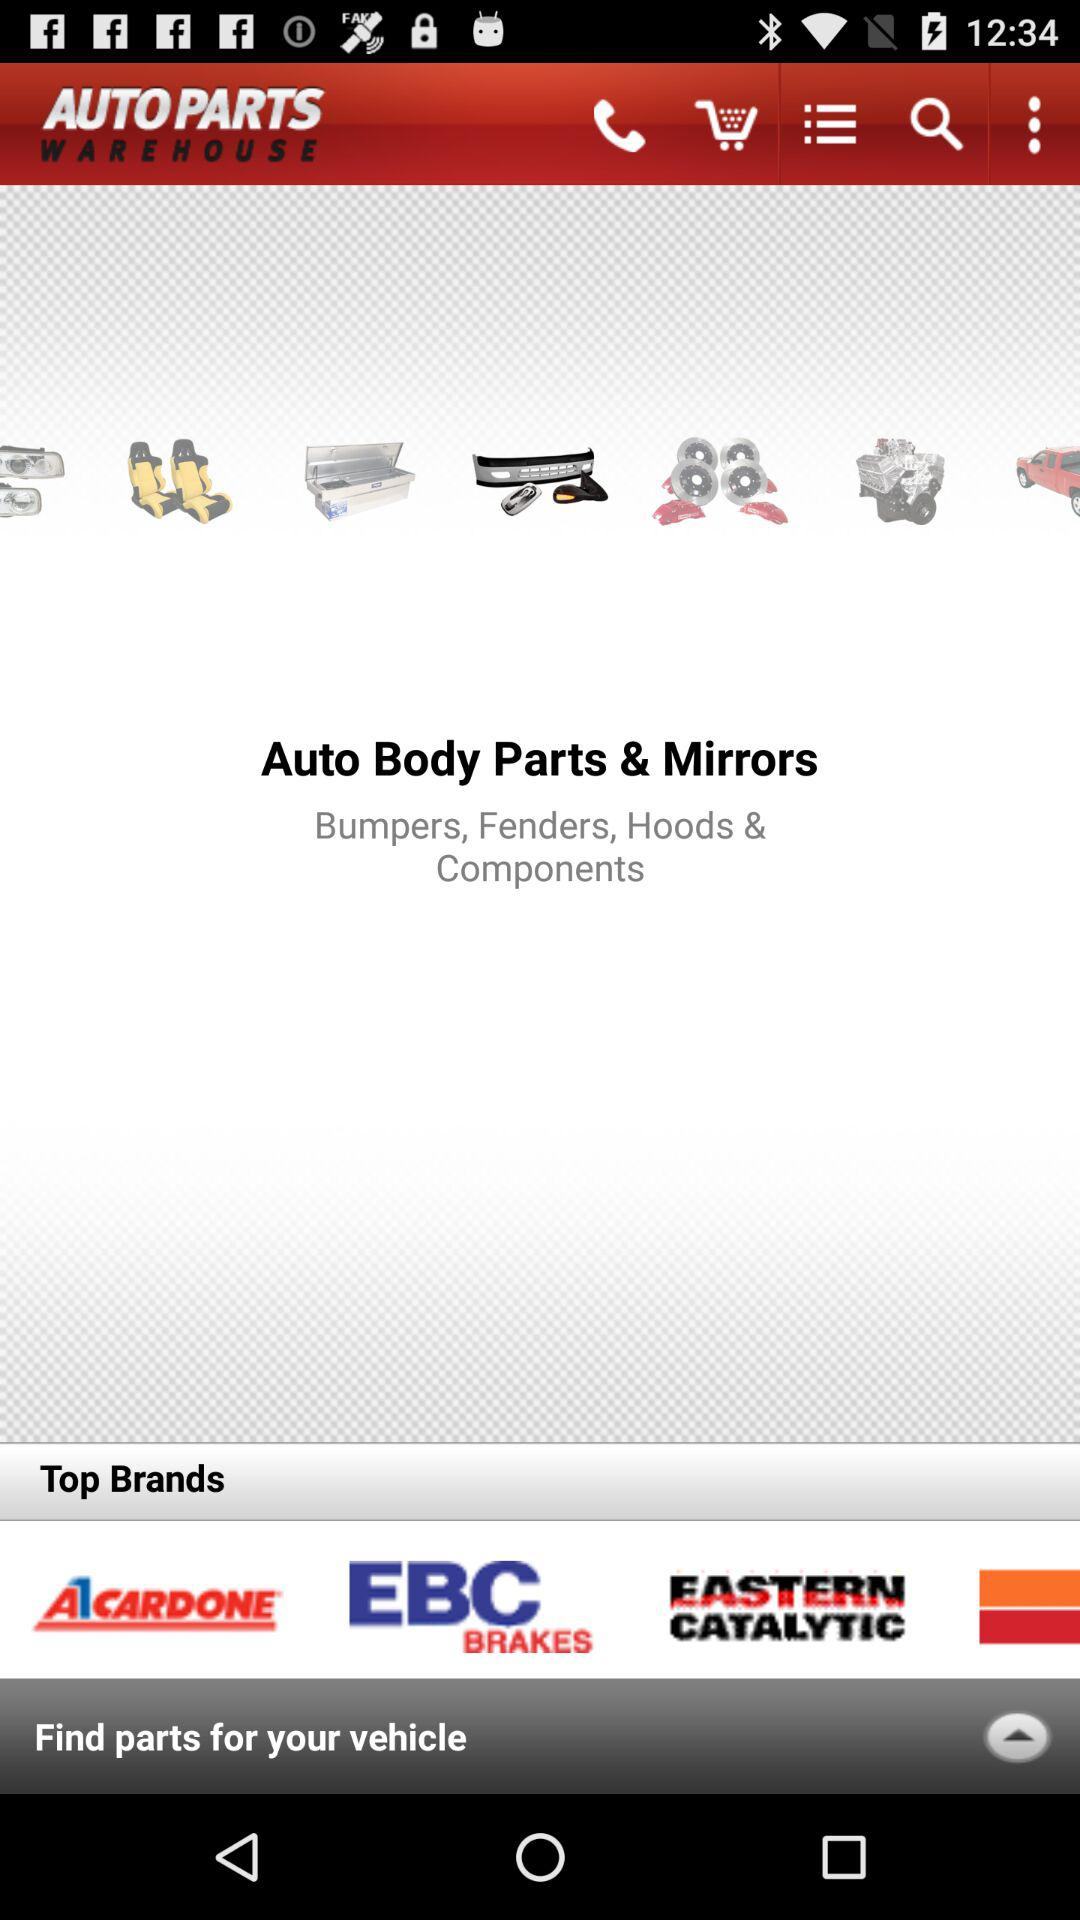How many unread messages are there?
When the provided information is insufficient, respond with <no answer>. <no answer> 